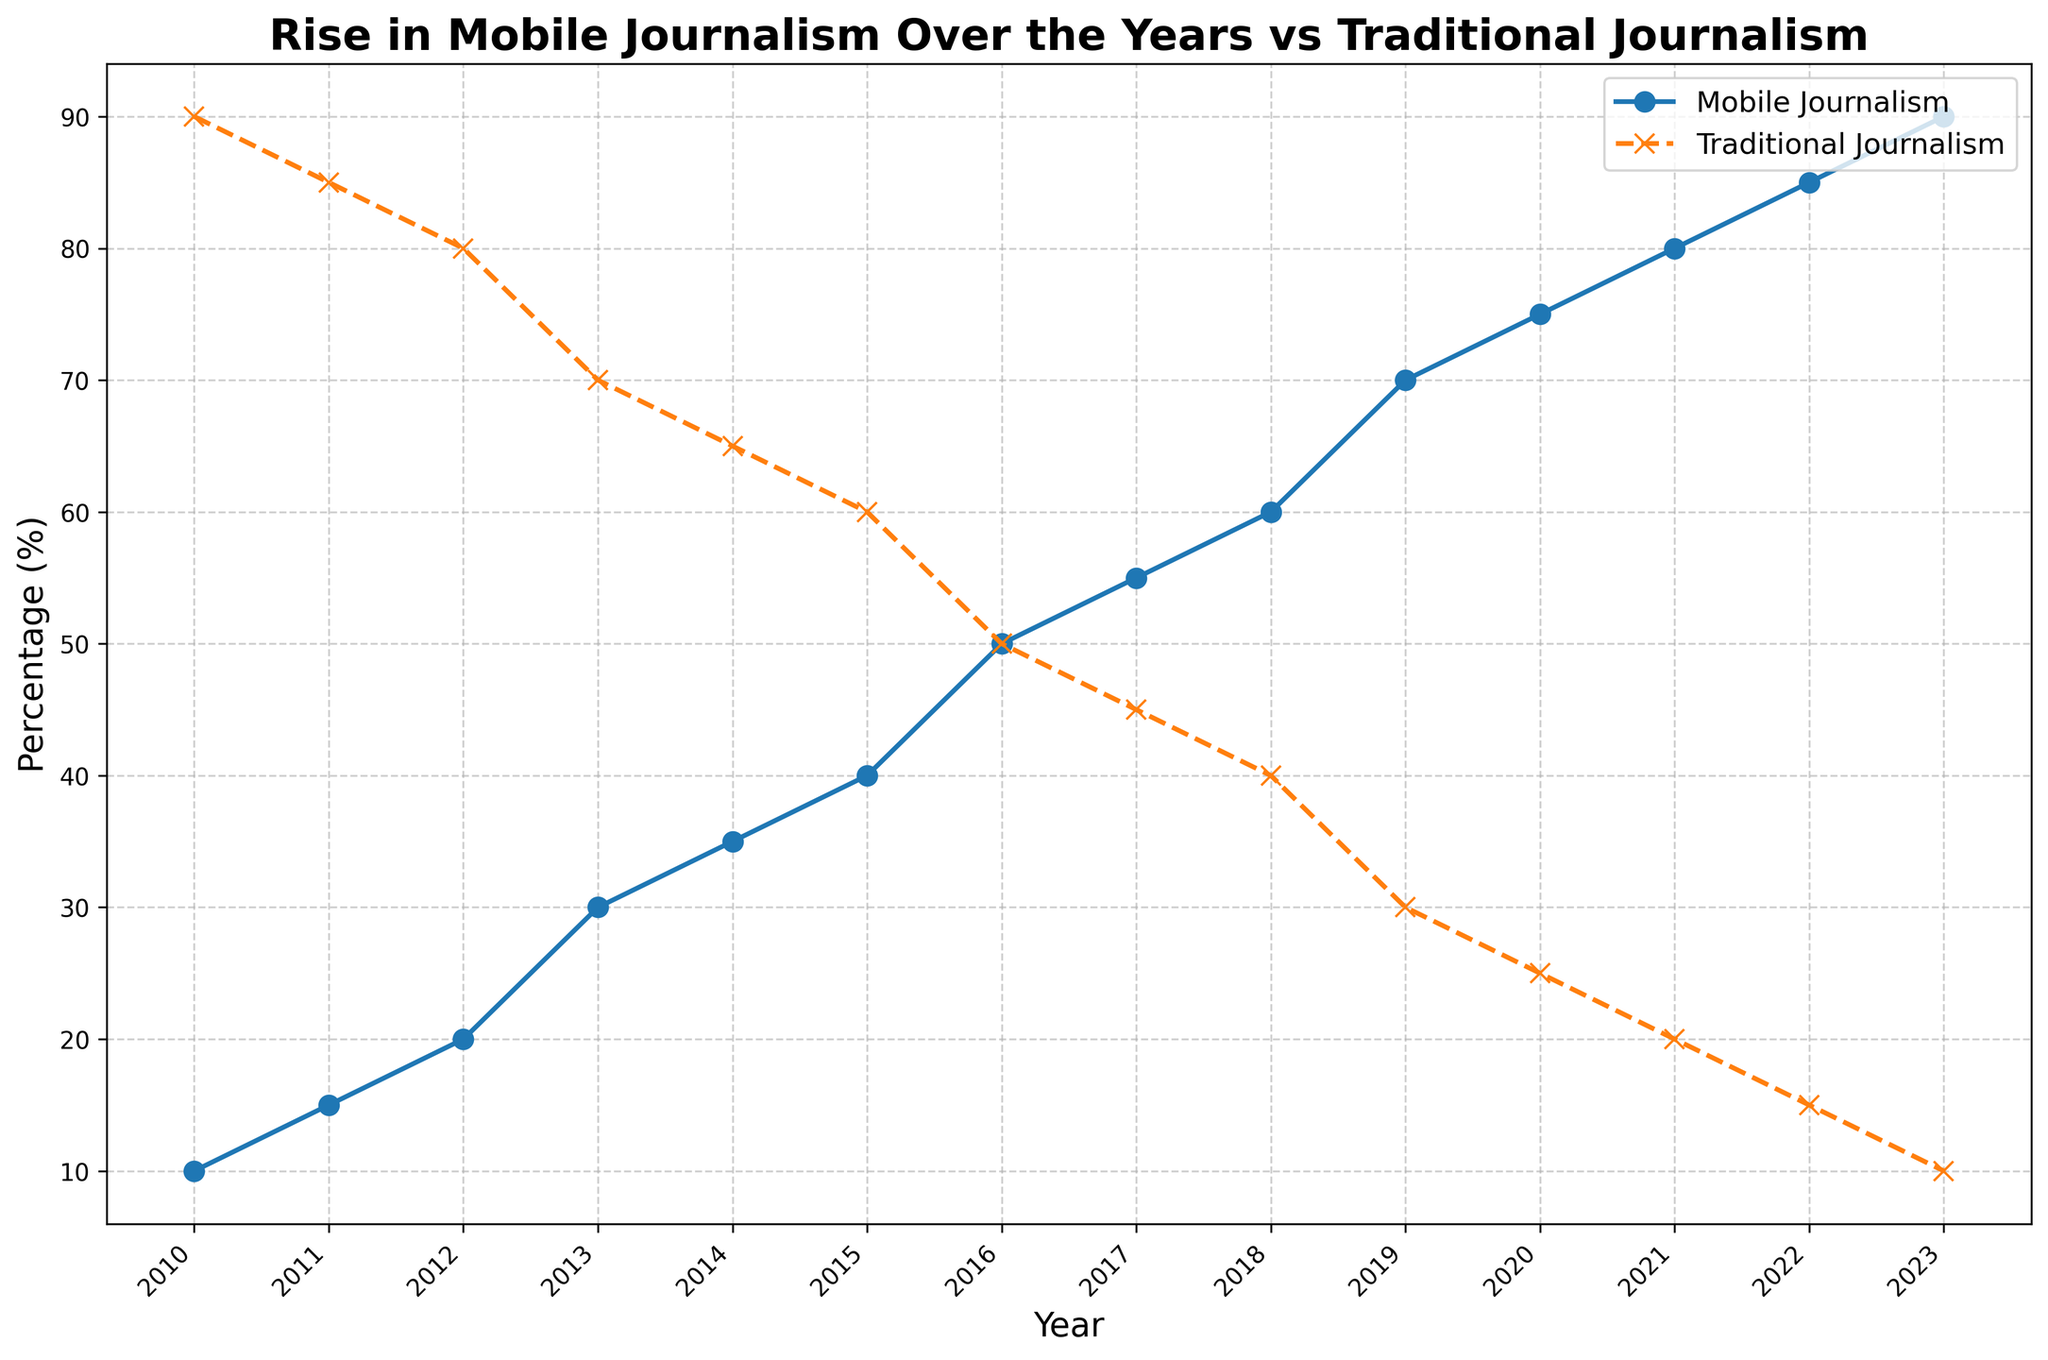What's the trend in the percentage of mobile journalism from 2010 to 2023? To determine the trend, observe the trajectory of the blue line representing mobile journalism over the years. It starts at 10% in 2010 and steadily increases to 90% in 2023. This indicates a clear upward trend.
Answer: Upward trend Which year shows an equal percentage of mobile journalism and traditional journalism? Look for the intersection point of the lines representing mobile journalism and traditional journalism. In 2016, both are at 50%.
Answer: 2016 How much did the percentage of traditional journalism decrease from 2010 to 2023? Subtract the percentage of traditional journalism in 2023 (10%) from the percentage in 2010 (90%). The decrease is 90% - 10% = 80%.
Answer: 80% By how much did mobile journalism increase from 2011 to 2016? Subtract the percentage of mobile journalism in 2011 (15%) from the percentage in 2016 (50%). The increase is 50% - 15% = 35%.
Answer: 35% Between which consecutive years did mobile journalism see the largest percentage increase? Calculate the year-over-year increases from 2010 to 2023 and identify the largest value. The largest increase happens between 2012 and 2013, where the percentage rises from 20% to 30%, an increase of 10%.
Answer: 2012 to 2013 Is the percentage of traditional journalism higher than mobile journalism in 2014? Compare the plotted values for both journalism types in 2014. Traditional journalism is at 65%, while mobile journalism is at 35%. Traditional journalism is higher.
Answer: Yes What is the difference in percentages between mobile journalism and traditional journalism in 2020? Subtract the percentage of traditional journalism in 2020 (25%) from the percentage of mobile journalism (75%). The difference is 75% - 25% = 50%.
Answer: 50% What's the average percentage of mobile journalism from 2010 to 2023? Sum the percentages of mobile journalism for the years 2010 to 2023 (10+15+20+30+35+40+50+55+60+70+75+80+85+90=715) and divide by the number of years (14). The average is 715 / 14 ≈ 51.07%.
Answer: 51.07% Which year marks the first time mobile journalism surpasses 50%? Observe the figure to find the year when the blue line (mobile journalism) crosses above 50%. This occurs in 2016.
Answer: 2016 From 2018 to 2022, what's the average annual increase in the percentage of mobile journalism? Calculate the increase from 2018 to 2022 (85% - 60% = 25%) and then divide by the number of years (2022 - 2018 = 4). The average annual increase is 25% / 4 = 6.25%.
Answer: 6.25% 